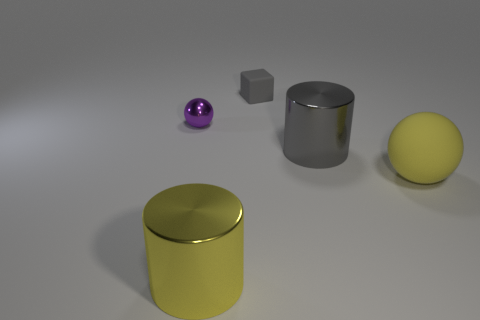There is a object that is to the left of the gray metal cylinder and right of the yellow metallic cylinder; what shape is it?
Your response must be concise. Cube. Are there any gray cylinders made of the same material as the large gray object?
Offer a terse response. No. What is the size of the metallic thing that is the same color as the large matte sphere?
Give a very brief answer. Large. There is a thing that is behind the purple object; what is its color?
Provide a succinct answer. Gray. Do the purple object and the matte thing that is in front of the purple metal sphere have the same shape?
Provide a succinct answer. Yes. Is there a large metal thing of the same color as the large rubber object?
Give a very brief answer. Yes. What is the size of the purple sphere that is made of the same material as the yellow cylinder?
Your answer should be compact. Small. Do the small ball and the tiny rubber block have the same color?
Offer a terse response. No. There is a yellow thing that is on the left side of the large ball; is it the same shape as the big gray object?
Provide a short and direct response. Yes. How many yellow rubber objects are the same size as the gray rubber object?
Offer a terse response. 0. 